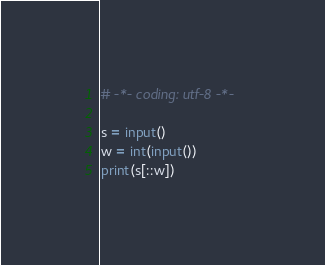<code> <loc_0><loc_0><loc_500><loc_500><_Python_># -*- coding: utf-8 -*-

s = input()
w = int(input())
print(s[::w])
</code> 